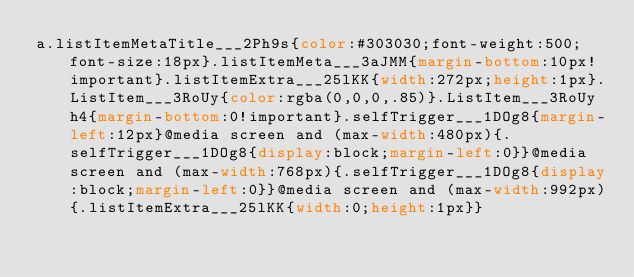<code> <loc_0><loc_0><loc_500><loc_500><_CSS_>a.listItemMetaTitle___2Ph9s{color:#303030;font-weight:500;font-size:18px}.listItemMeta___3aJMM{margin-bottom:10px!important}.listItemExtra___25lKK{width:272px;height:1px}.ListItem___3RoUy{color:rgba(0,0,0,.85)}.ListItem___3RoUy h4{margin-bottom:0!important}.selfTrigger___1DOg8{margin-left:12px}@media screen and (max-width:480px){.selfTrigger___1DOg8{display:block;margin-left:0}}@media screen and (max-width:768px){.selfTrigger___1DOg8{display:block;margin-left:0}}@media screen and (max-width:992px){.listItemExtra___25lKK{width:0;height:1px}}</code> 